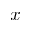<formula> <loc_0><loc_0><loc_500><loc_500>x</formula> 